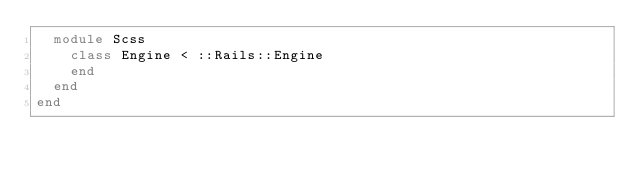Convert code to text. <code><loc_0><loc_0><loc_500><loc_500><_Ruby_>  module Scss
    class Engine < ::Rails::Engine
    end
  end
end
</code> 